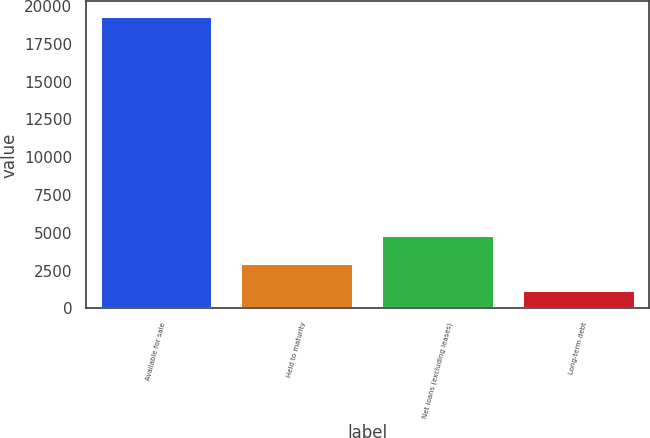Convert chart to OTSL. <chart><loc_0><loc_0><loc_500><loc_500><bar_chart><fcel>Available for sale<fcel>Held to maturity<fcel>Net loans (excluding leases)<fcel>Long-term debt<nl><fcel>19338<fcel>3029.1<fcel>4841.2<fcel>1217<nl></chart> 